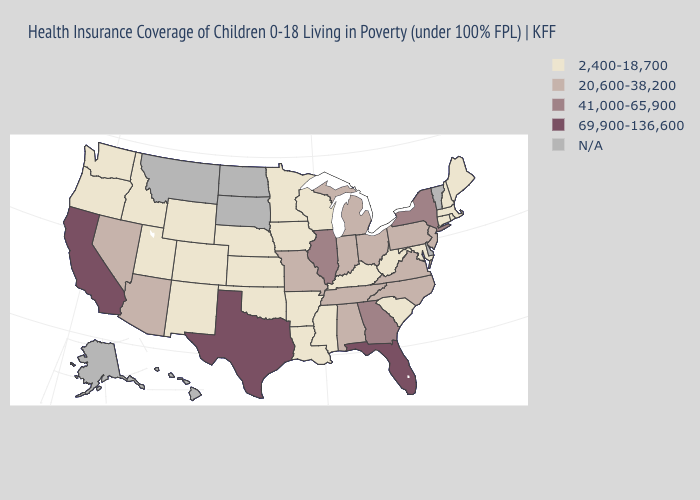What is the highest value in the West ?
Be succinct. 69,900-136,600. Does the first symbol in the legend represent the smallest category?
Quick response, please. Yes. Which states hav the highest value in the MidWest?
Write a very short answer. Illinois. Among the states that border New Hampshire , which have the lowest value?
Short answer required. Maine, Massachusetts. What is the value of Iowa?
Quick response, please. 2,400-18,700. What is the highest value in states that border Nebraska?
Short answer required. 20,600-38,200. Which states have the lowest value in the USA?
Give a very brief answer. Arkansas, Colorado, Connecticut, Idaho, Iowa, Kansas, Kentucky, Louisiana, Maine, Maryland, Massachusetts, Minnesota, Mississippi, Nebraska, New Hampshire, New Mexico, Oklahoma, Oregon, Rhode Island, South Carolina, Utah, Washington, West Virginia, Wisconsin, Wyoming. What is the highest value in the MidWest ?
Keep it brief. 41,000-65,900. Name the states that have a value in the range 20,600-38,200?
Give a very brief answer. Alabama, Arizona, Indiana, Michigan, Missouri, Nevada, New Jersey, North Carolina, Ohio, Pennsylvania, Tennessee, Virginia. What is the value of South Carolina?
Keep it brief. 2,400-18,700. What is the highest value in the MidWest ?
Write a very short answer. 41,000-65,900. Does Pennsylvania have the lowest value in the Northeast?
Short answer required. No. What is the value of Alaska?
Concise answer only. N/A. 